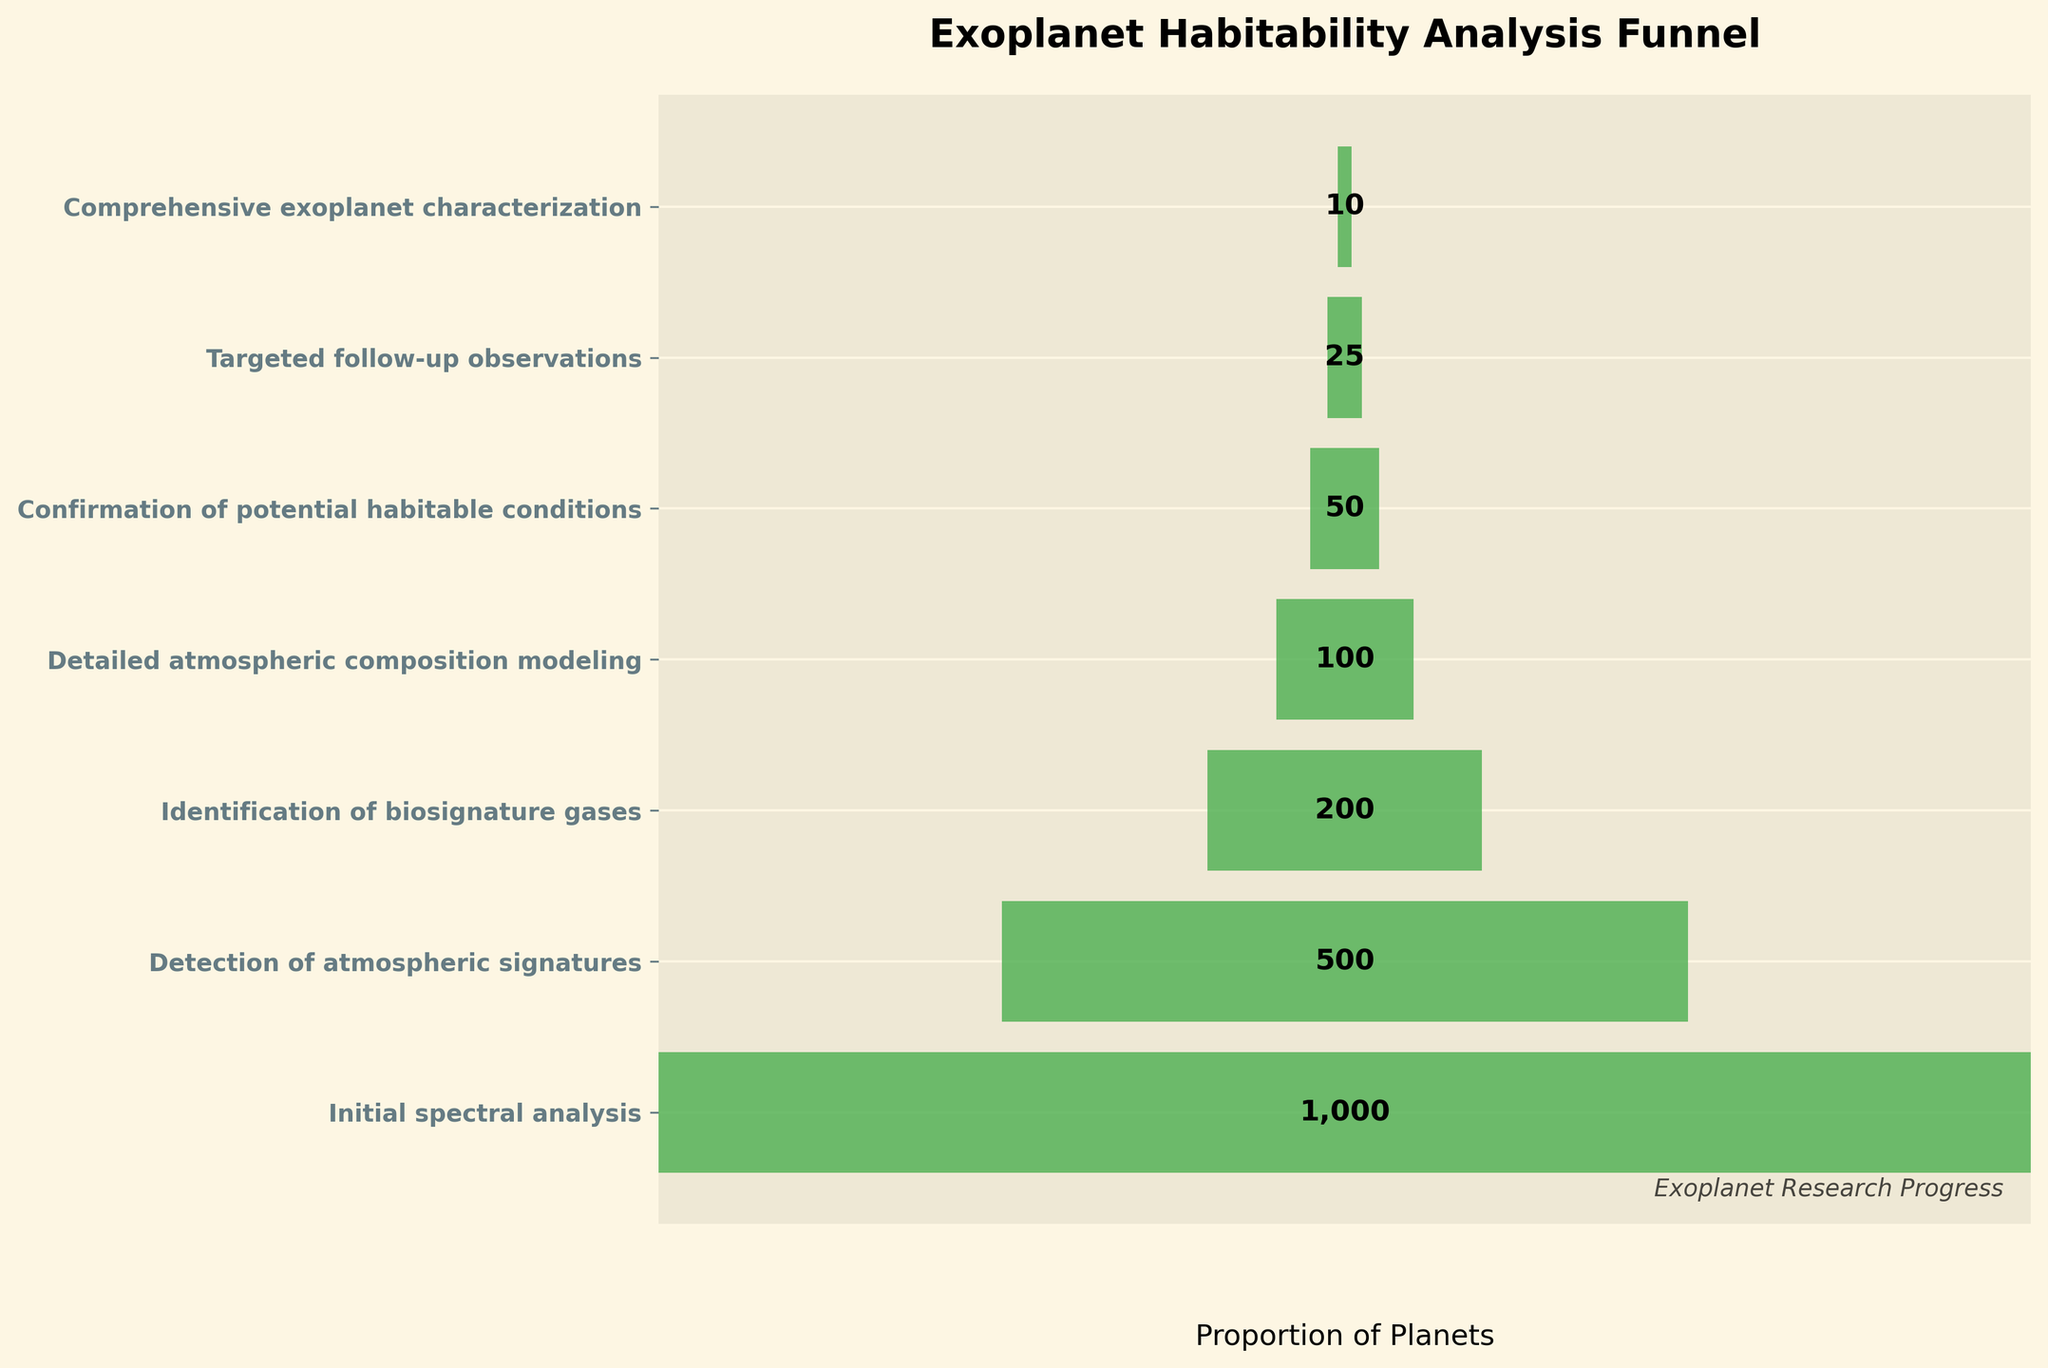What is the title of the chart? The title is prominently displayed at the top of the chart.
Answer: Exoplanet Habitability Analysis Funnel How many steps are there in the funnel chart? Count the number of distinct labeled steps on the y-axis.
Answer: Seven Which step screens the highest number of planets? Identify the step at the widest part of the funnel, indicating the largest number of planets.
Answer: Initial spectral analysis How many planets successfully pass through the initial spectral analysis step? The number of planets is labeled directly next to the corresponding step.
Answer: 1000 What is the width range used to represent the proportion of planets in the funnel chart? The width of the bars signifies the proportion of the planets, ranging from 0 to the maximum.
Answer: 0 to 1 How many planets are analyzed in the final step of comprehensive exoplanet characterization? The number is labeled directly next to the final step in the funnel.
Answer: 10 By how many do the planets decrease from the detection of atmospheric signatures to identification of biosignature gases? Subtract the number of planets in the identification of biosignature gases step from the detection of atmospheric signatures.
Answer: 500 - 200 = 300 What percentage of planets in the initial spectral analysis proceed to the detection of atmospheric signatures step? Divide the number of planets proceeding to the detection stage by the initial number and multiply by 100.
Answer: (500 / 1000) * 100 = 50% Which step has half the number of planets compared to the detailed atmospheric composition modeling step? Identify the step where the planet count is half of 100, which is the number in the detailed atmospheric composition modeling step.
Answer: Confirmation of potential habitable conditions Between which two consecutive steps is the largest proportional decrease in the number of planets observed? Calculate the proportional decrease for each consecutive step and identify the largest drop.
Answer: Identification of biosignature gases to detailed atmospheric composition modeling Is the number of planets that reach targeted follow-up observations greater than or less than 1/10th of those in the initial spectral analysis? Calculate and compare 1/10th of the initial spectral analysis to the number at targeted follow-up observations step.
Answer: Less than (100 < 25) 